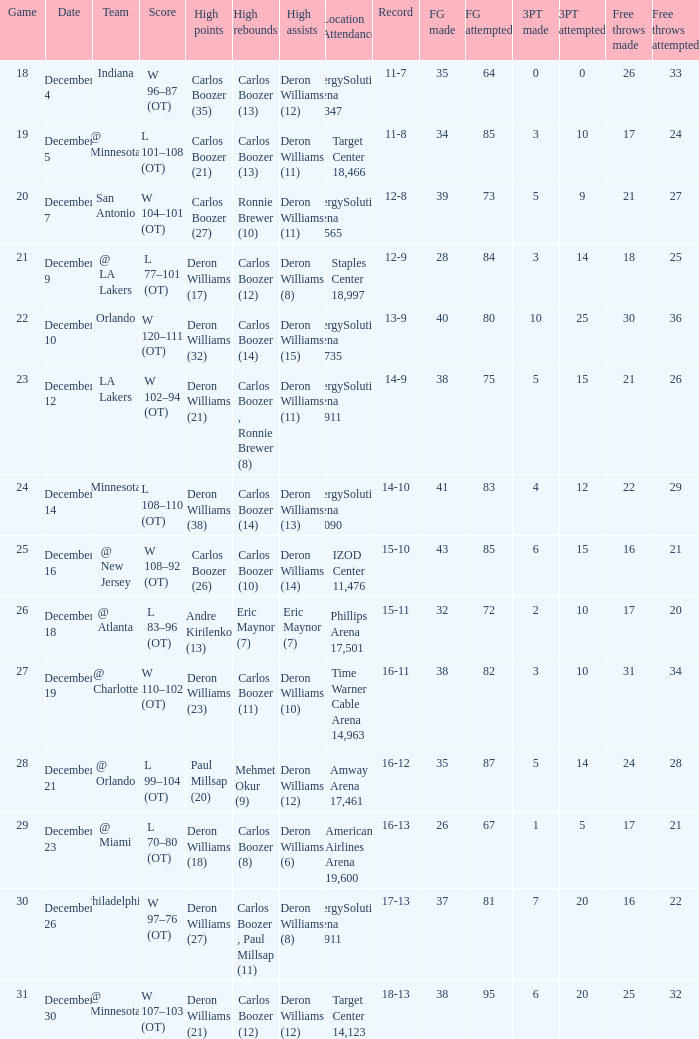What's the number of the game in which Carlos Boozer (8) did the high rebounds? 29.0. 